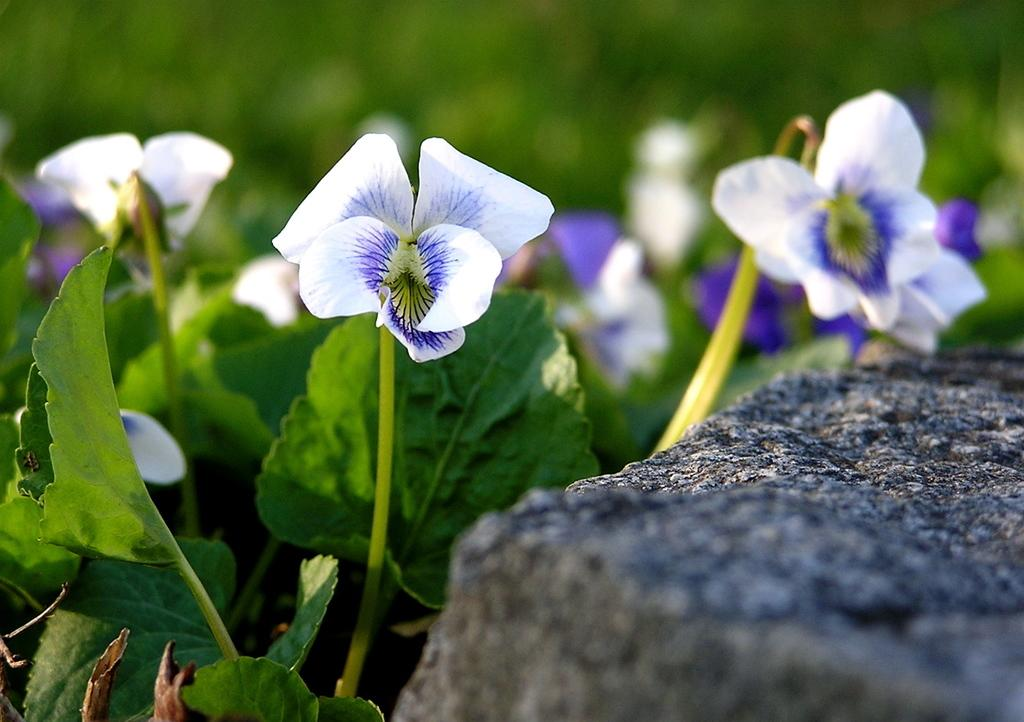What type of flowers can be seen on the plant in the image? There are white flowers and purple flowers on a plant in the image. What is the plant located in front of in the image? The plant is in front of a rock in the image. What type of knowledge can be gained from the flowers in the image? The flowers in the image do not convey any specific knowledge; they are simply a visual element in the image. 